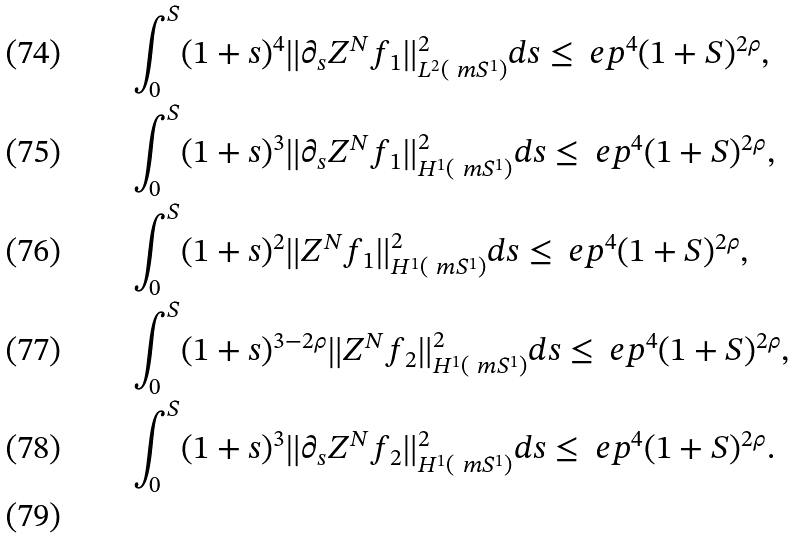Convert formula to latex. <formula><loc_0><loc_0><loc_500><loc_500>& \int _ { 0 } ^ { S } ( 1 + s ) ^ { 4 } \| \partial _ { s } Z ^ { N } f _ { 1 } \| _ { L ^ { 2 } ( \ m S ^ { 1 } ) } ^ { 2 } d s \leq \ e p ^ { 4 } ( 1 + S ) ^ { 2 \rho } , \\ & \int _ { 0 } ^ { S } ( 1 + s ) ^ { 3 } \| \partial _ { s } Z ^ { N } f _ { 1 } \| _ { H ^ { 1 } ( \ m S ^ { 1 } ) } ^ { 2 } d s \leq \ e p ^ { 4 } ( 1 + S ) ^ { 2 \rho } , \\ & \int _ { 0 } ^ { S } ( 1 + s ) ^ { 2 } \| Z ^ { N } f _ { 1 } \| _ { H ^ { 1 } ( \ m S ^ { 1 } ) } ^ { 2 } d s \leq \ e p ^ { 4 } ( 1 + S ) ^ { 2 \rho } , \\ & \int _ { 0 } ^ { S } ( 1 + s ) ^ { 3 - 2 \rho } \| Z ^ { N } f _ { 2 } \| ^ { 2 } _ { H ^ { 1 } ( \ m S ^ { 1 } ) } d s \leq \ e p ^ { 4 } ( 1 + S ) ^ { 2 \rho } , \\ & \int _ { 0 } ^ { S } ( 1 + s ) ^ { 3 } \| \partial _ { s } Z ^ { N } f _ { 2 } \| ^ { 2 } _ { H ^ { 1 } ( \ m S ^ { 1 } ) } d s \leq \ e p ^ { 4 } ( 1 + S ) ^ { 2 \rho } . \\</formula> 